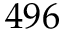<formula> <loc_0><loc_0><loc_500><loc_500>4 9 6</formula> 